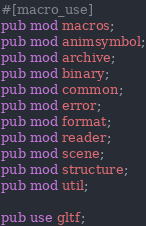Convert code to text. <code><loc_0><loc_0><loc_500><loc_500><_Rust_>#[macro_use]
pub mod macros;
pub mod animsymbol;
pub mod archive;
pub mod binary;
pub mod common;
pub mod error;
pub mod format;
pub mod reader;
pub mod scene;
pub mod structure;
pub mod util;

pub use gltf;
</code> 